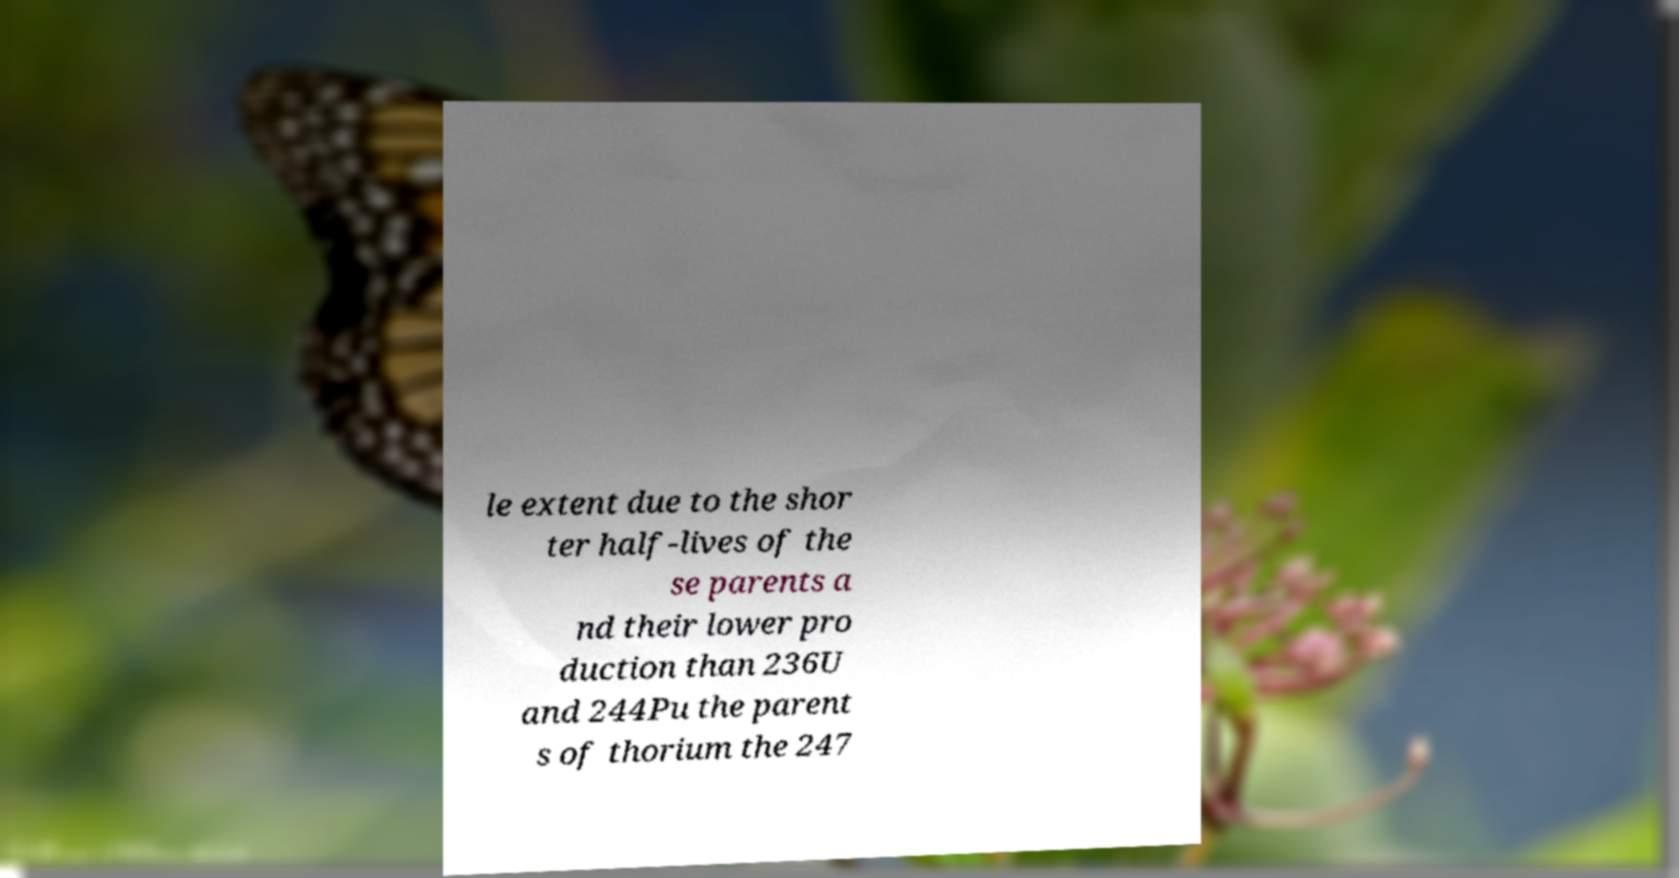Please identify and transcribe the text found in this image. le extent due to the shor ter half-lives of the se parents a nd their lower pro duction than 236U and 244Pu the parent s of thorium the 247 